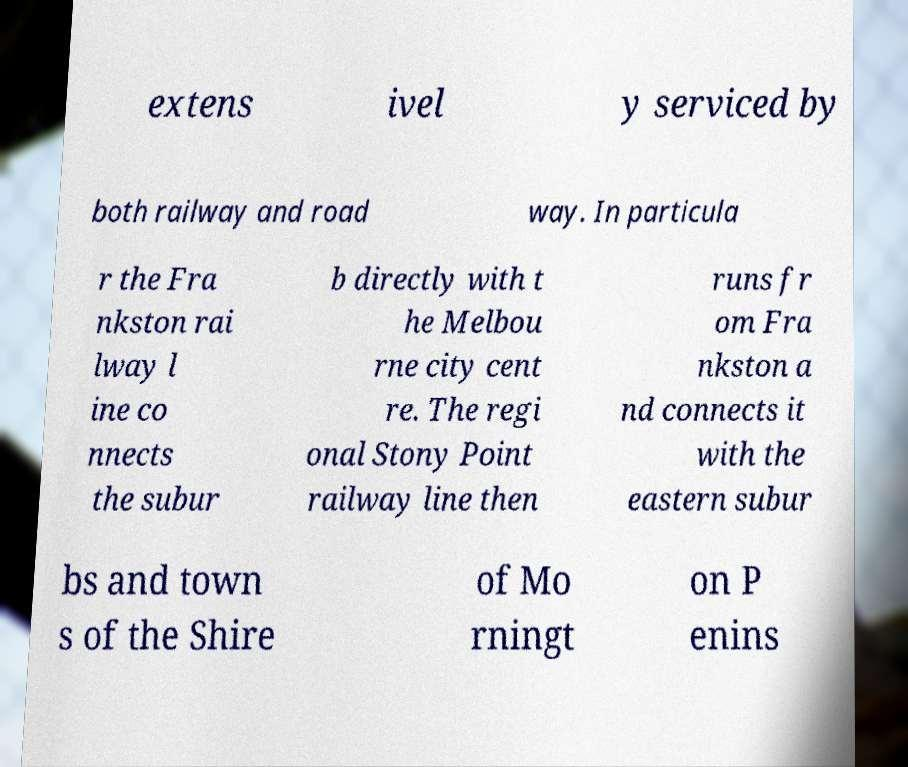There's text embedded in this image that I need extracted. Can you transcribe it verbatim? extens ivel y serviced by both railway and road way. In particula r the Fra nkston rai lway l ine co nnects the subur b directly with t he Melbou rne city cent re. The regi onal Stony Point railway line then runs fr om Fra nkston a nd connects it with the eastern subur bs and town s of the Shire of Mo rningt on P enins 